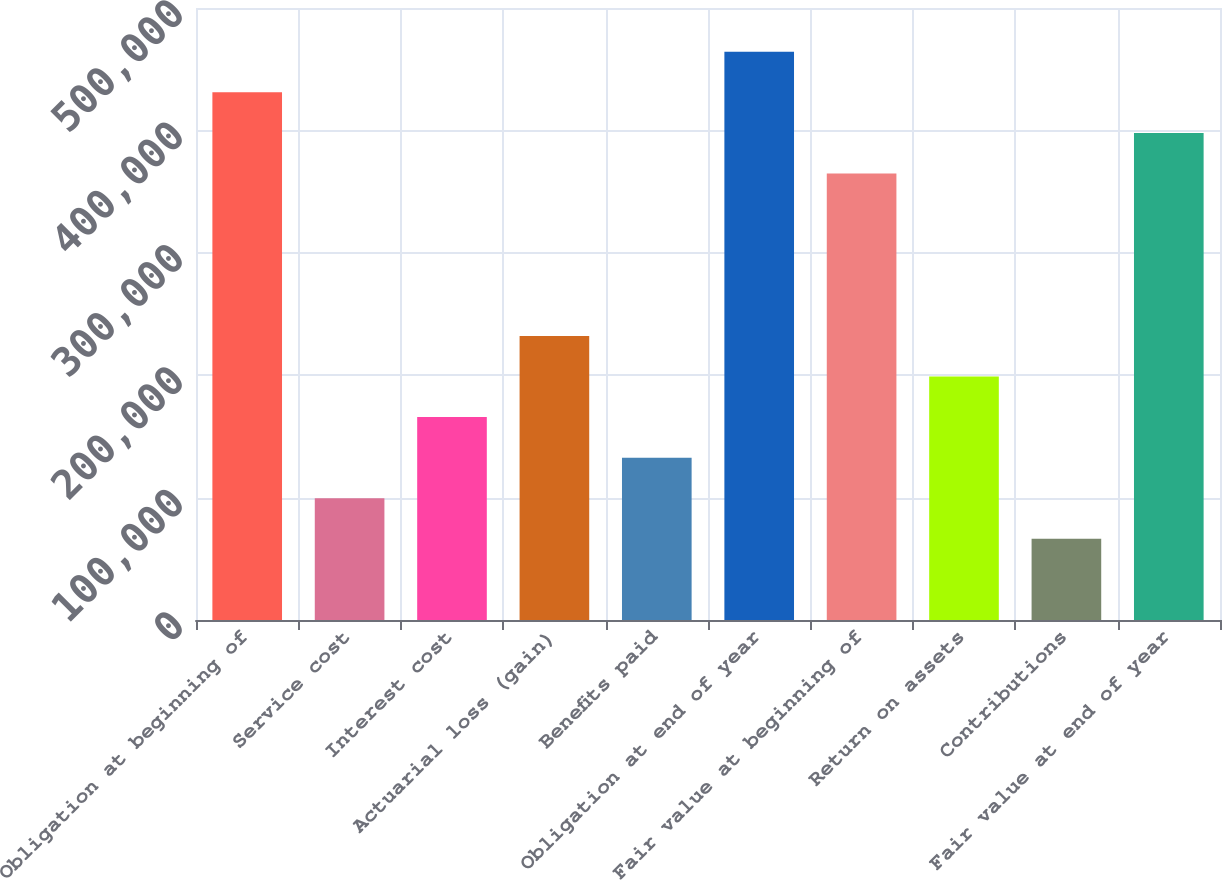Convert chart. <chart><loc_0><loc_0><loc_500><loc_500><bar_chart><fcel>Obligation at beginning of<fcel>Service cost<fcel>Interest cost<fcel>Actuarial loss (gain)<fcel>Benefits paid<fcel>Obligation at end of year<fcel>Fair value at beginning of<fcel>Return on assets<fcel>Contributions<fcel>Fair value at end of year<nl><fcel>431091<fcel>99484.6<fcel>165806<fcel>232127<fcel>132645<fcel>464251<fcel>364770<fcel>198966<fcel>66324<fcel>397930<nl></chart> 